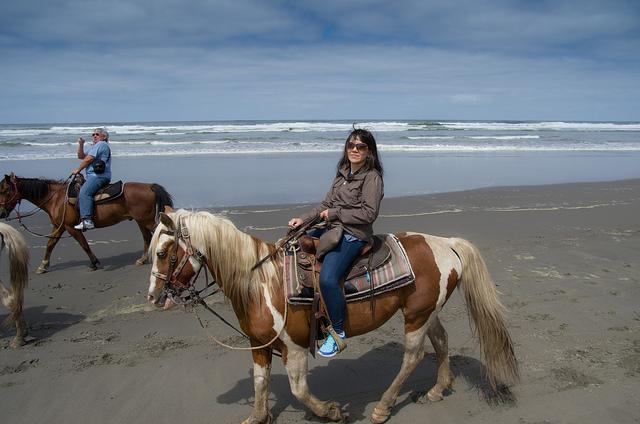How many horses are there?
Give a very brief answer. 3. How many sheep are facing the camera?
Give a very brief answer. 0. 